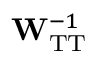<formula> <loc_0><loc_0><loc_500><loc_500>W _ { T T } ^ { - 1 }</formula> 